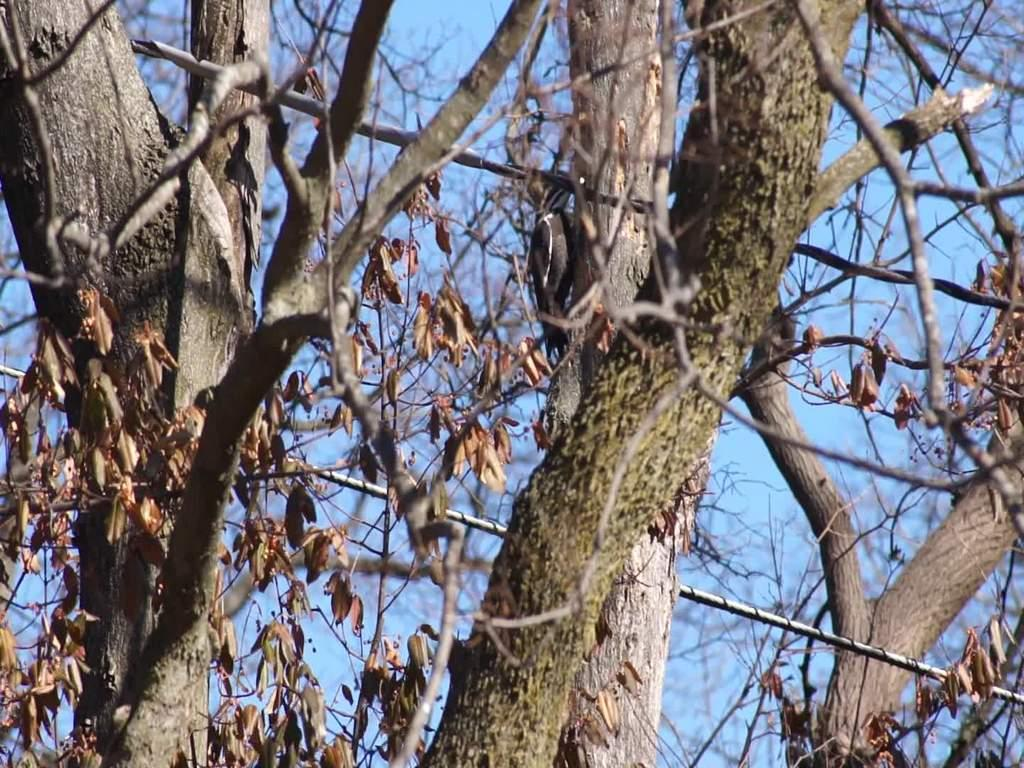What is the main subject in the middle of the image? There is a bird in the middle of the image. What type of natural environment can be seen in the image? There are trees visible in the image. Are there any man-made structures or objects in the image? Yes, there are cables in the image. What type of insurance does the bird have in the image? There is no information about the bird's insurance in the image. Can you see any cracks in the bird's beak in the image? There is no mention of the bird's beak or any cracks in the image. 